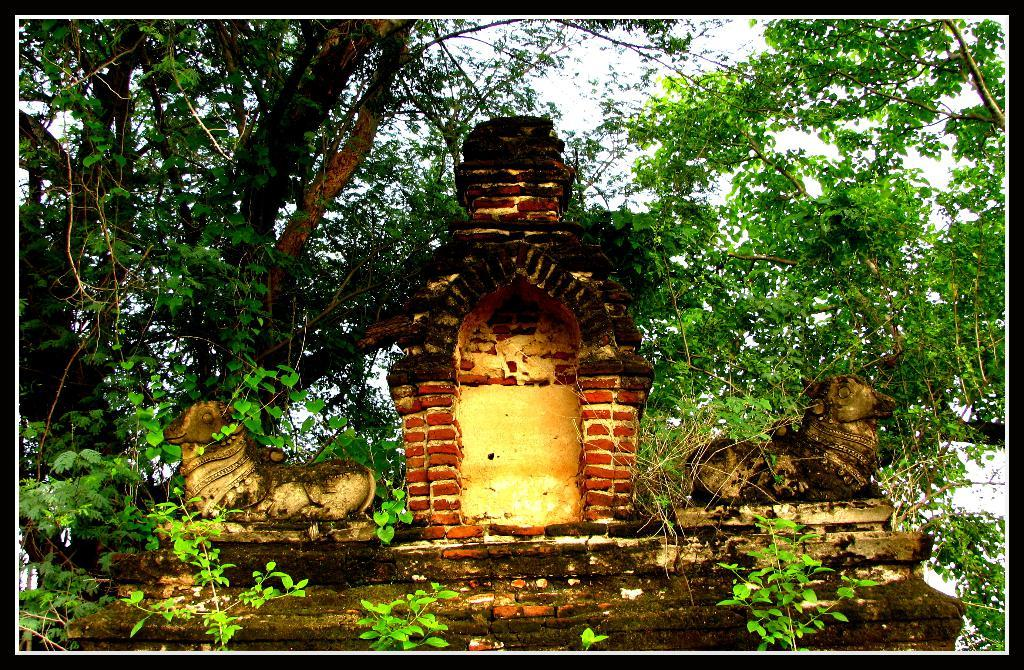What is located in the middle of the image? There is a wall in the middle of the image. What can be seen on either side of the wall? There are statues on either side of the wall. What type of vegetation is visible in the background of the image? There are trees in the background of the image. What is visible at the top of the image? The sky is visible at the top of the image. What type of sand can be seen in the image? There is no sand present in the image. What kind of trouble is the wall causing in the image? The wall is not causing any trouble in the image; it is simply a part of the scene. 